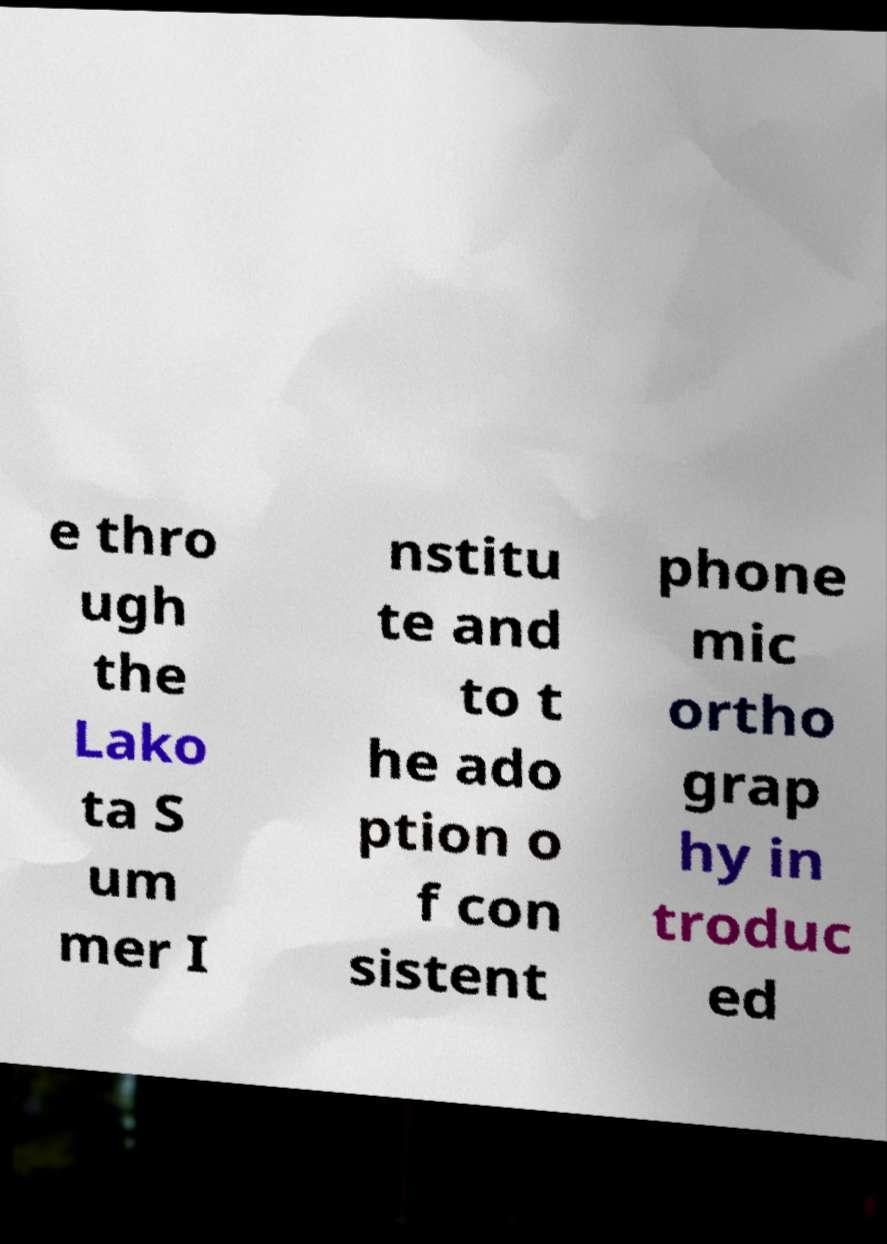Can you read and provide the text displayed in the image?This photo seems to have some interesting text. Can you extract and type it out for me? e thro ugh the Lako ta S um mer I nstitu te and to t he ado ption o f con sistent phone mic ortho grap hy in troduc ed 